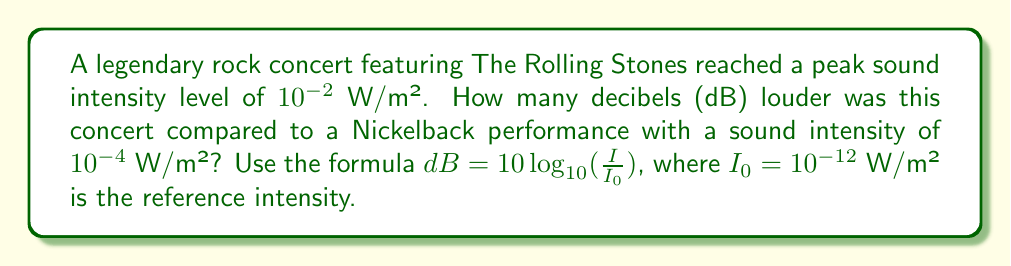Give your solution to this math problem. Let's approach this step-by-step:

1) We need to calculate the decibel level for both concerts and then find the difference.

2) For The Rolling Stones concert:
   $$dB_1 = 10 \log_{10}(\frac{I_1}{I_0}) = 10 \log_{10}(\frac{10^{-2}}{10^{-12}}) = 10 \log_{10}(10^{10}) = 10 \cdot 10 = 100 \text{ dB}$$

3) For the Nickelback concert:
   $$dB_2 = 10 \log_{10}(\frac{I_2}{I_0}) = 10 \log_{10}(\frac{10^{-4}}{10^{-12}}) = 10 \log_{10}(10^8) = 10 \cdot 8 = 80 \text{ dB}$$

4) The difference in decibels:
   $$\Delta dB = dB_1 - dB_2 = 100 - 80 = 20 \text{ dB}$$

5) Therefore, The Rolling Stones concert was 20 dB louder than the Nickelback performance.
Answer: 20 dB 